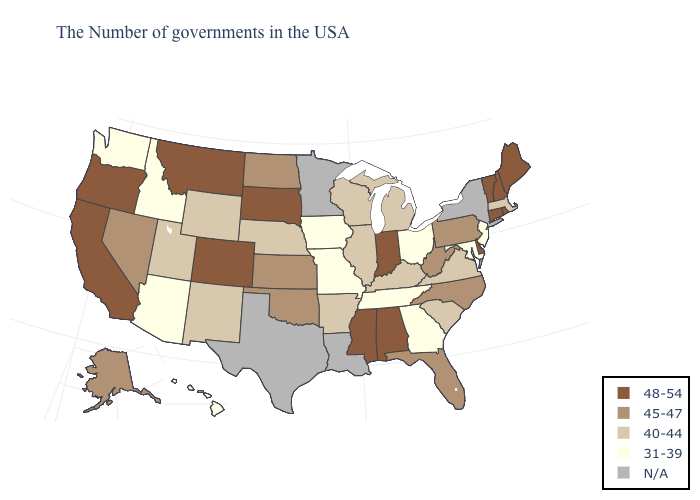Does Pennsylvania have the highest value in the USA?
Short answer required. No. What is the value of New Mexico?
Concise answer only. 40-44. Does Mississippi have the lowest value in the South?
Answer briefly. No. What is the value of Delaware?
Concise answer only. 48-54. What is the value of Texas?
Answer briefly. N/A. Name the states that have a value in the range 40-44?
Answer briefly. Massachusetts, Virginia, South Carolina, Michigan, Kentucky, Wisconsin, Illinois, Arkansas, Nebraska, Wyoming, New Mexico, Utah. Name the states that have a value in the range 40-44?
Be succinct. Massachusetts, Virginia, South Carolina, Michigan, Kentucky, Wisconsin, Illinois, Arkansas, Nebraska, Wyoming, New Mexico, Utah. What is the value of Kentucky?
Be succinct. 40-44. Does the map have missing data?
Be succinct. Yes. Does Arkansas have the highest value in the USA?
Be succinct. No. Which states have the highest value in the USA?
Keep it brief. Maine, Rhode Island, New Hampshire, Vermont, Connecticut, Delaware, Indiana, Alabama, Mississippi, South Dakota, Colorado, Montana, California, Oregon. Name the states that have a value in the range N/A?
Be succinct. New York, Louisiana, Minnesota, Texas. Among the states that border Vermont , which have the highest value?
Write a very short answer. New Hampshire. Name the states that have a value in the range 31-39?
Write a very short answer. New Jersey, Maryland, Ohio, Georgia, Tennessee, Missouri, Iowa, Arizona, Idaho, Washington, Hawaii. 